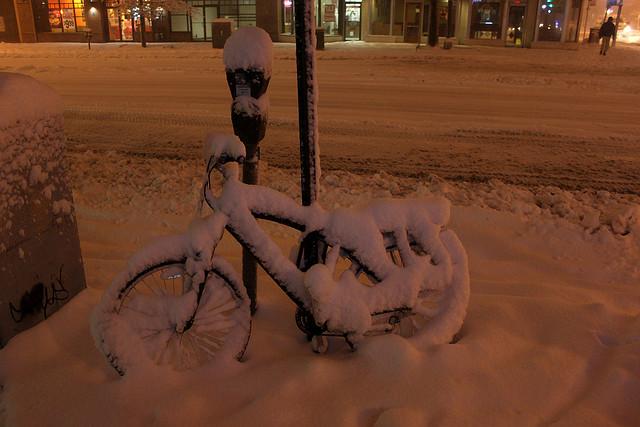What is covering the bike?
Write a very short answer. Snow. What time of year is the picture taken?
Be succinct. Winter. Is there a bike in the photo?
Keep it brief. Yes. 